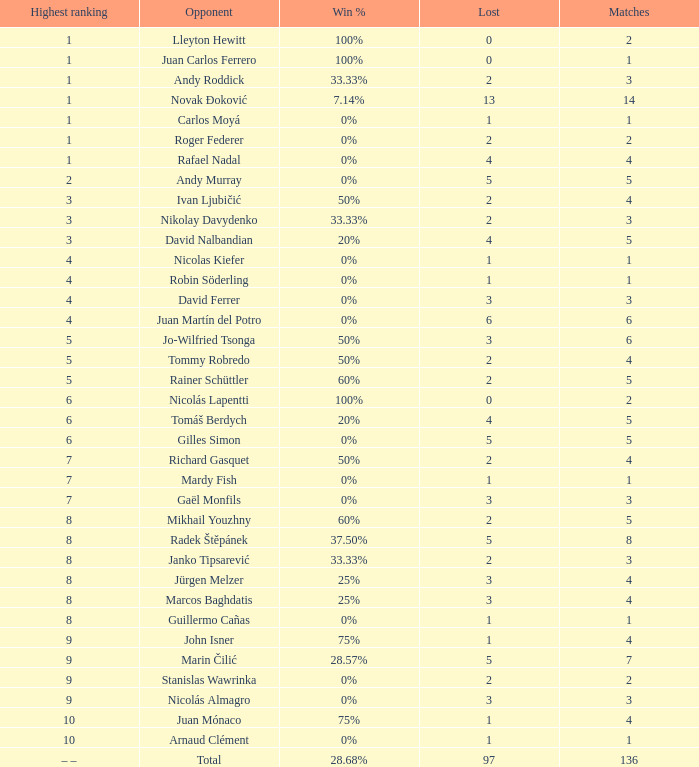What is the largest number Lost to david nalbandian with a Win Rate of 20%? 4.0. 